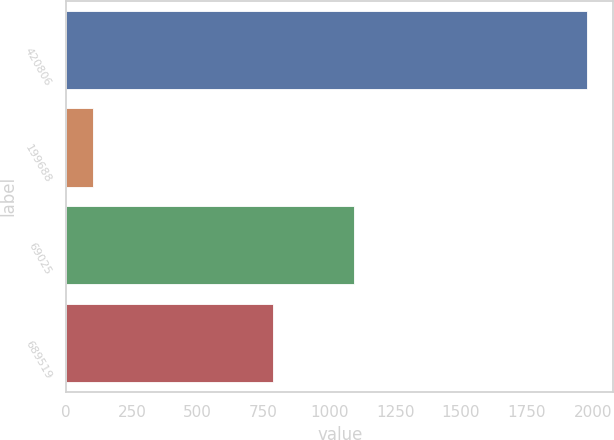Convert chart to OTSL. <chart><loc_0><loc_0><loc_500><loc_500><bar_chart><fcel>420806<fcel>199688<fcel>69025<fcel>689519<nl><fcel>1980<fcel>102<fcel>1093<fcel>785<nl></chart> 